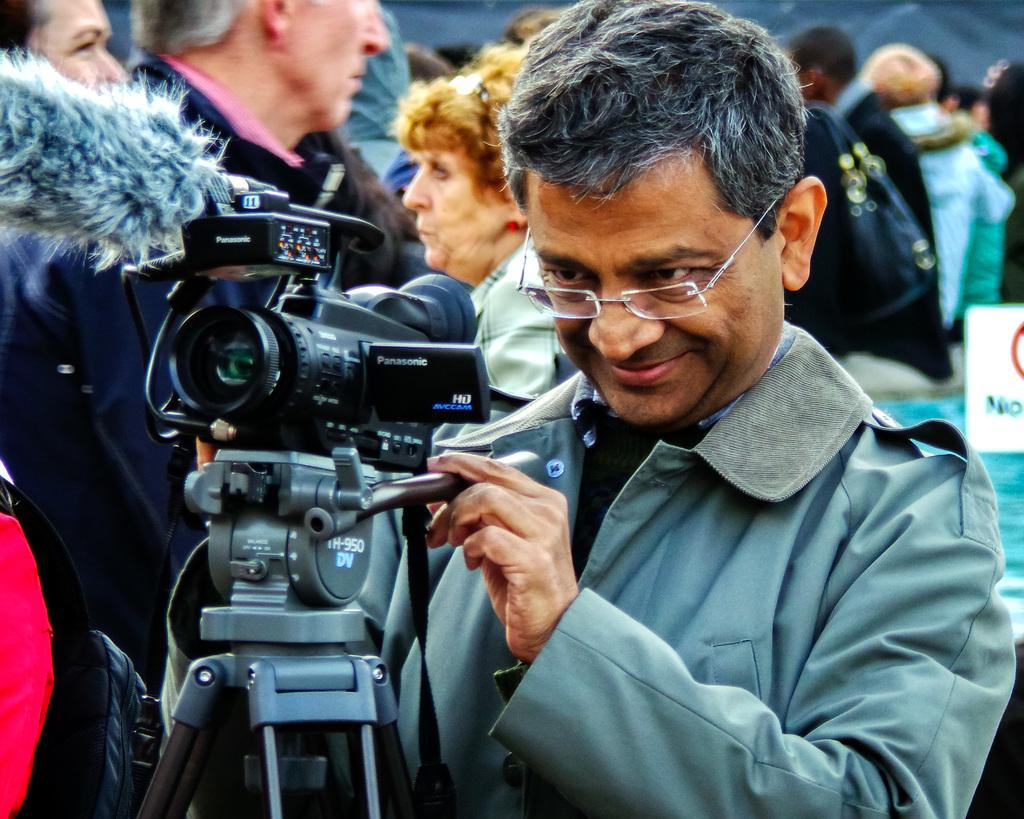Who is the main subject in the image? There is a man in the image. Where is the man positioned in the image? The man is standing at the center of the image. What is the man holding in the image? The man is holding a camera. How is the camera positioned in relation to the man? The camera is in front of the man. What is the man's facial expression in the image? The man is smiling. Can you describe the people in the background of the image? There are persons in the background of the image. What type of engine is visible in the image? There is no engine present in the image. How much money is the man holding in the image? The man is holding a camera, not money, in the image. 